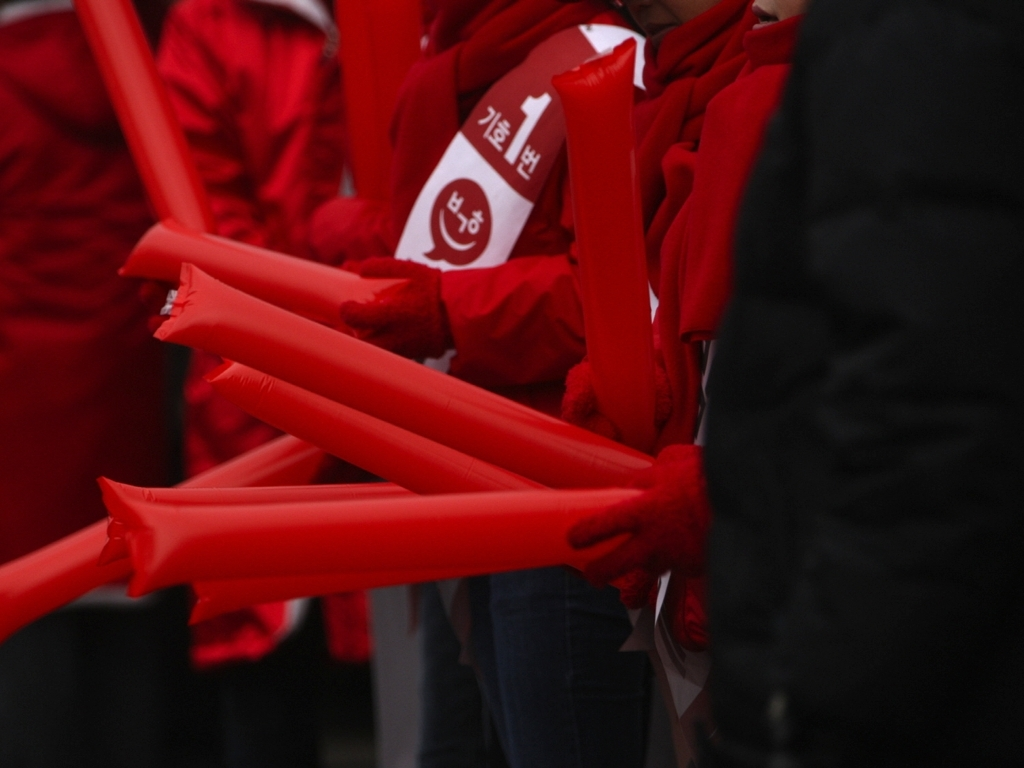Can you describe what these red objects are and perhaps speculate on the event? The red objects in this image appear to be inflatable sticks, commonly used at sports events or political rallies for cheering or showing support. The sea of red and focused handling suggests this could be part of a coordinated group activity, likely a rally or public gathering of sorts where color plays a symbolic role. 